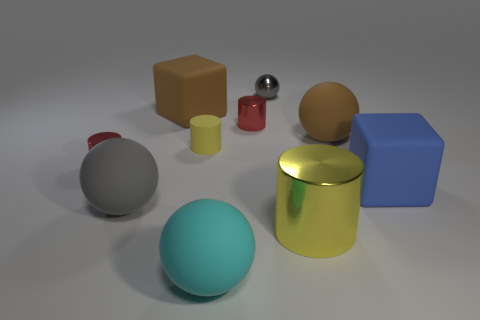If I were to group the objects by size, how would you categorize them? I would arrange them into three categories: large objects comprise the blue cube and the yellow cylinder; medium objects include the teal sphere, beige cylinder, and gray sphere; and the small objects consist of the red cylinder and the metallic shiny sphere. 